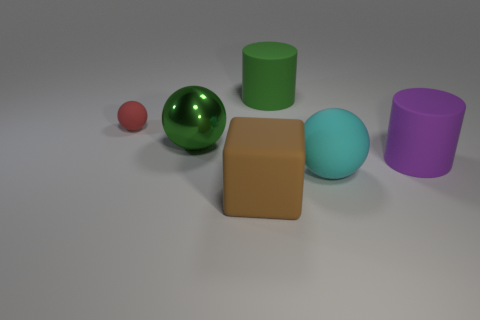Add 1 large blue rubber cubes. How many objects exist? 7 Subtract all cylinders. How many objects are left? 4 Subtract all tiny cyan cylinders. Subtract all large brown rubber things. How many objects are left? 5 Add 4 large metallic things. How many large metallic things are left? 5 Add 2 big blue matte balls. How many big blue matte balls exist? 2 Subtract 0 yellow cylinders. How many objects are left? 6 